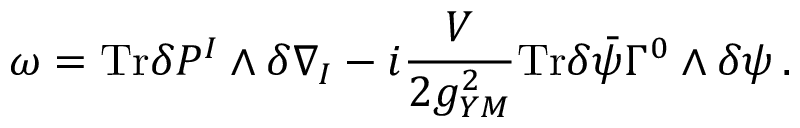Convert formula to latex. <formula><loc_0><loc_0><loc_500><loc_500>\omega = T r \delta P ^ { I } \wedge \delta \nabla _ { I } - i \frac { V } { 2 g _ { Y M } ^ { 2 } } T r \delta \bar { \psi } \Gamma ^ { 0 } \wedge \delta \psi \, .</formula> 